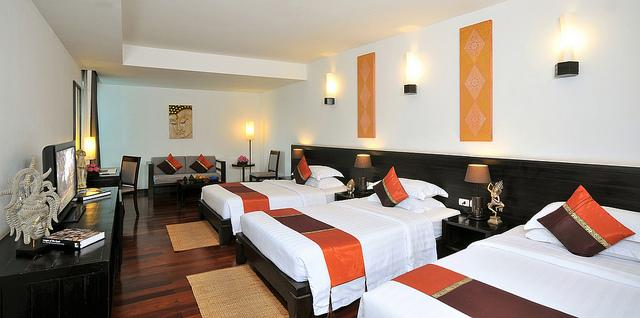In what continent is this hotel likely to be located?

Choices:
A) asia
B) africa
C) europe
D) north america asia 